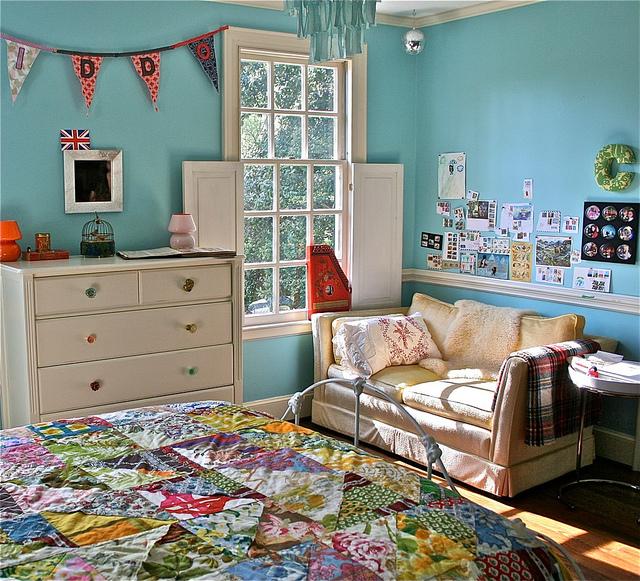How many drawers are there?
Write a very short answer. 5. Is the window open or closed?
Short answer required. Closed. What country's flag is above the frame?
Write a very short answer. England. 